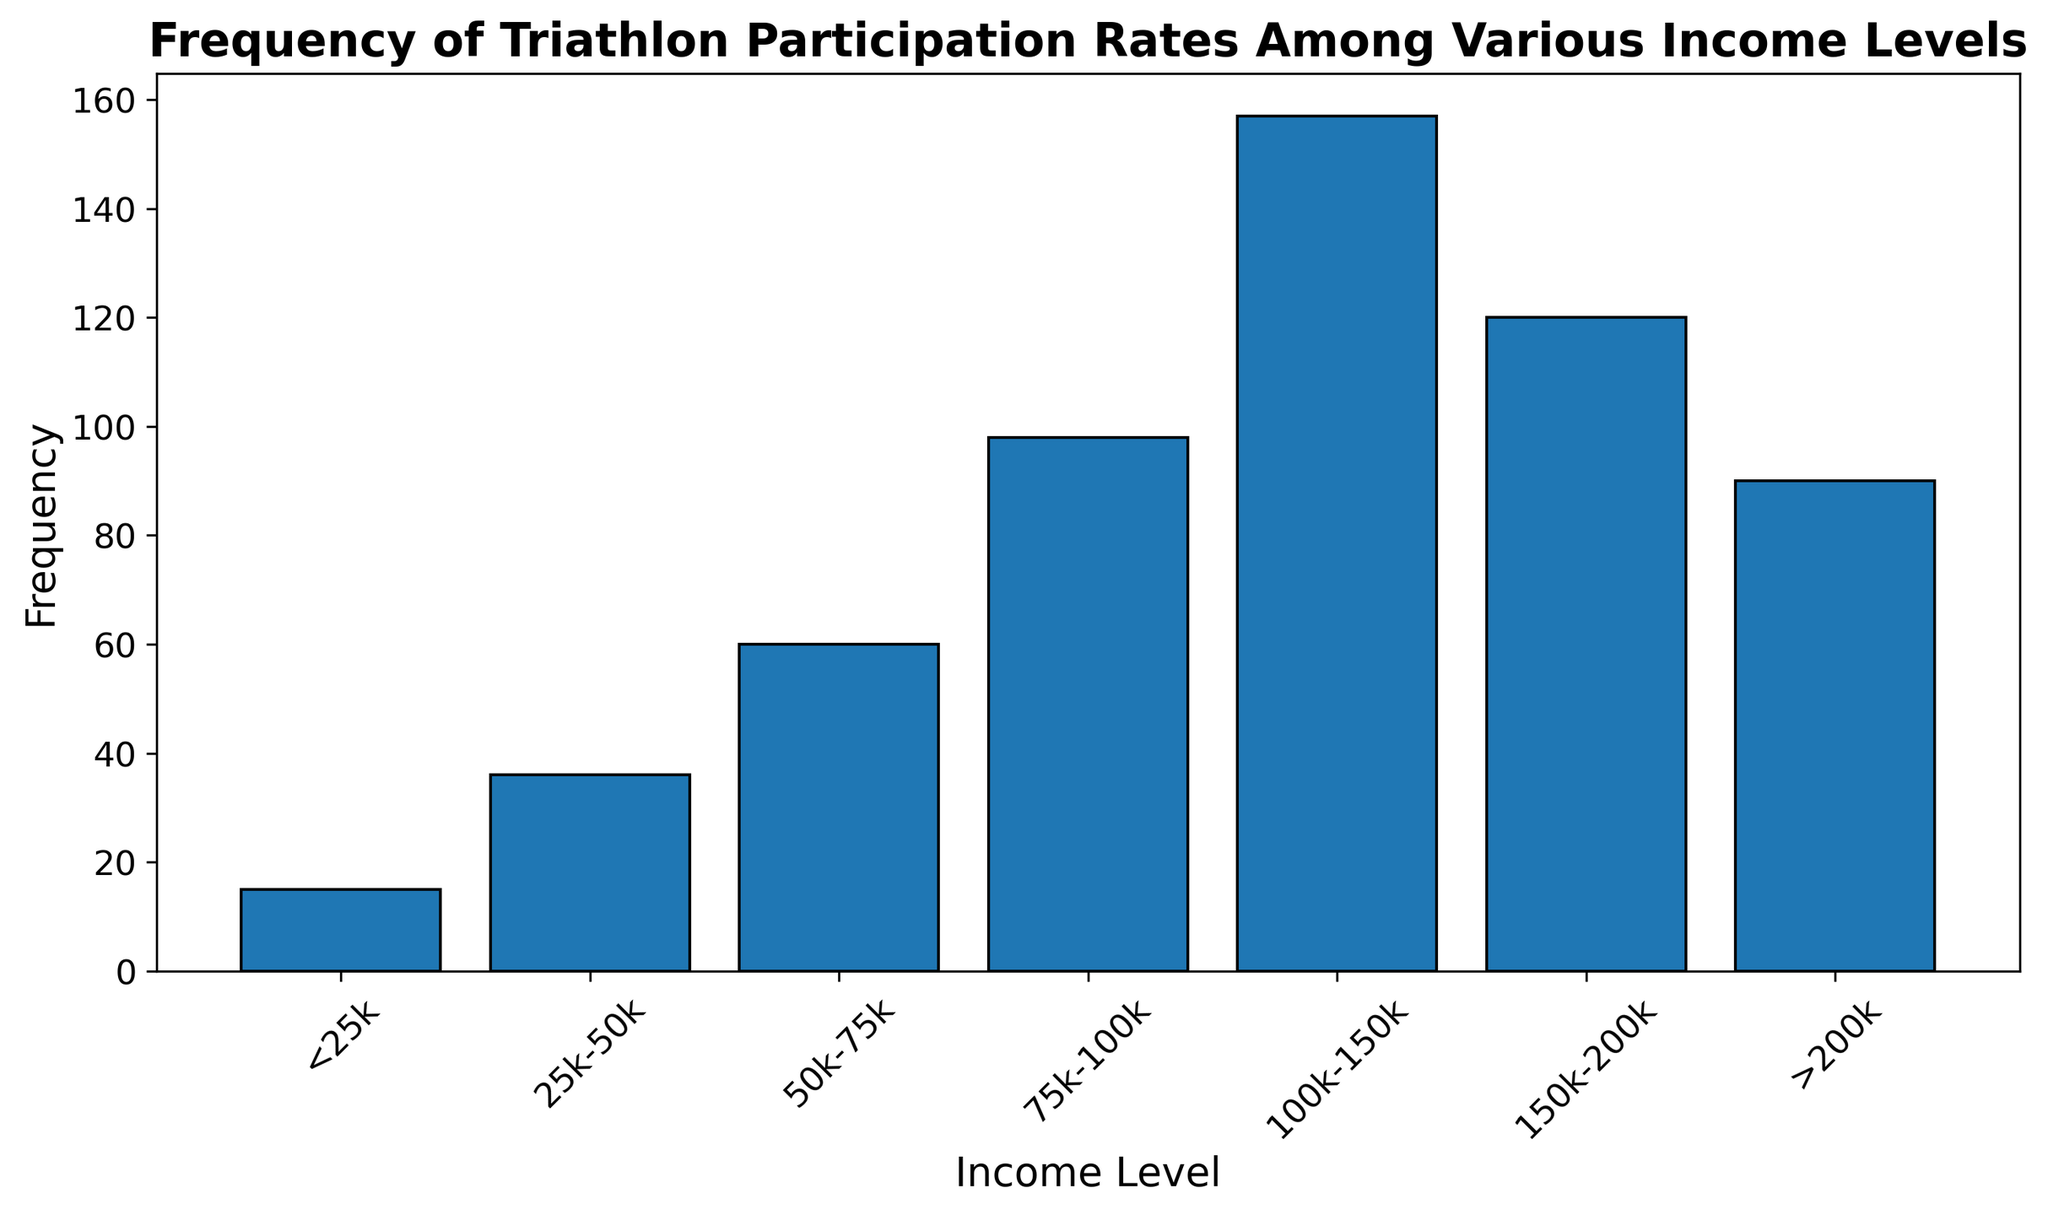Which income level has the highest frequency of triathlon participation? Looking at the height of the bars, the "100k-150k" income level has the highest bar, indicating the highest frequency.
Answer: 100k-150k Which income level has the lowest frequency of triathlon participation? The "<25k" income level has the shortest bar, indicating the lowest frequency.
Answer: <25k What's the total frequency of triathlon participation for income levels below 100k? Add the frequencies of the bars corresponding to "<25k", "25k-50k", "50k-75k", and "75k-100k": 15 + 36 + 60 + 98 = 209.
Answer: 209 How does the frequency of participation for income levels above 150k compare to those below 50k? Above 150k is the sum frequency for "150k-200k" and ">200k": 120. Below 50k is the sum for "<25k" and "25k-50k": 51. 120 > 51.
Answer: Above 150k is higher What is the combined frequency for the two highest income categories? The two highest income categories are "150k-200k" and ">200k". Add their frequencies: 120 + 90 = 210.
Answer: 210 What is the difference in frequency between the "75k-100k" income level and the "100k-150k" income level? The "75k-100k" has a frequency of 98, and the "100k-150k" has a frequency of 157. The difference is 157 - 98 = 59.
Answer: 59 Which income level has the second-highest frequency of triathlon participation? The bar next to the highest bar corresponds to "150k-200k", indicating the second-highest frequency.
Answer: 150k-200k How does the frequency for "50k-75k" compare to "25k-50k"? The bar for "50k-75k" is higher than the bar for "25k-50k". Frequencies are 60 and 36 respectively. 60 > 36.
Answer: 50k-75k is higher What visual attribute is used to differentiate the frequency of participation across different income levels? The height of the bars represents the frequency, with taller bars indicating higher frequencies.
Answer: Bar height What is the average frequency of triathlon participation for income levels between 50k and 150k? The income levels between 50k and 150k are "50k-75k", "75k-100k", and "100k-150k". Sum their frequencies: 60 + 98 + 157 = 315. The average is 315 / 3 = 105.
Answer: 105 